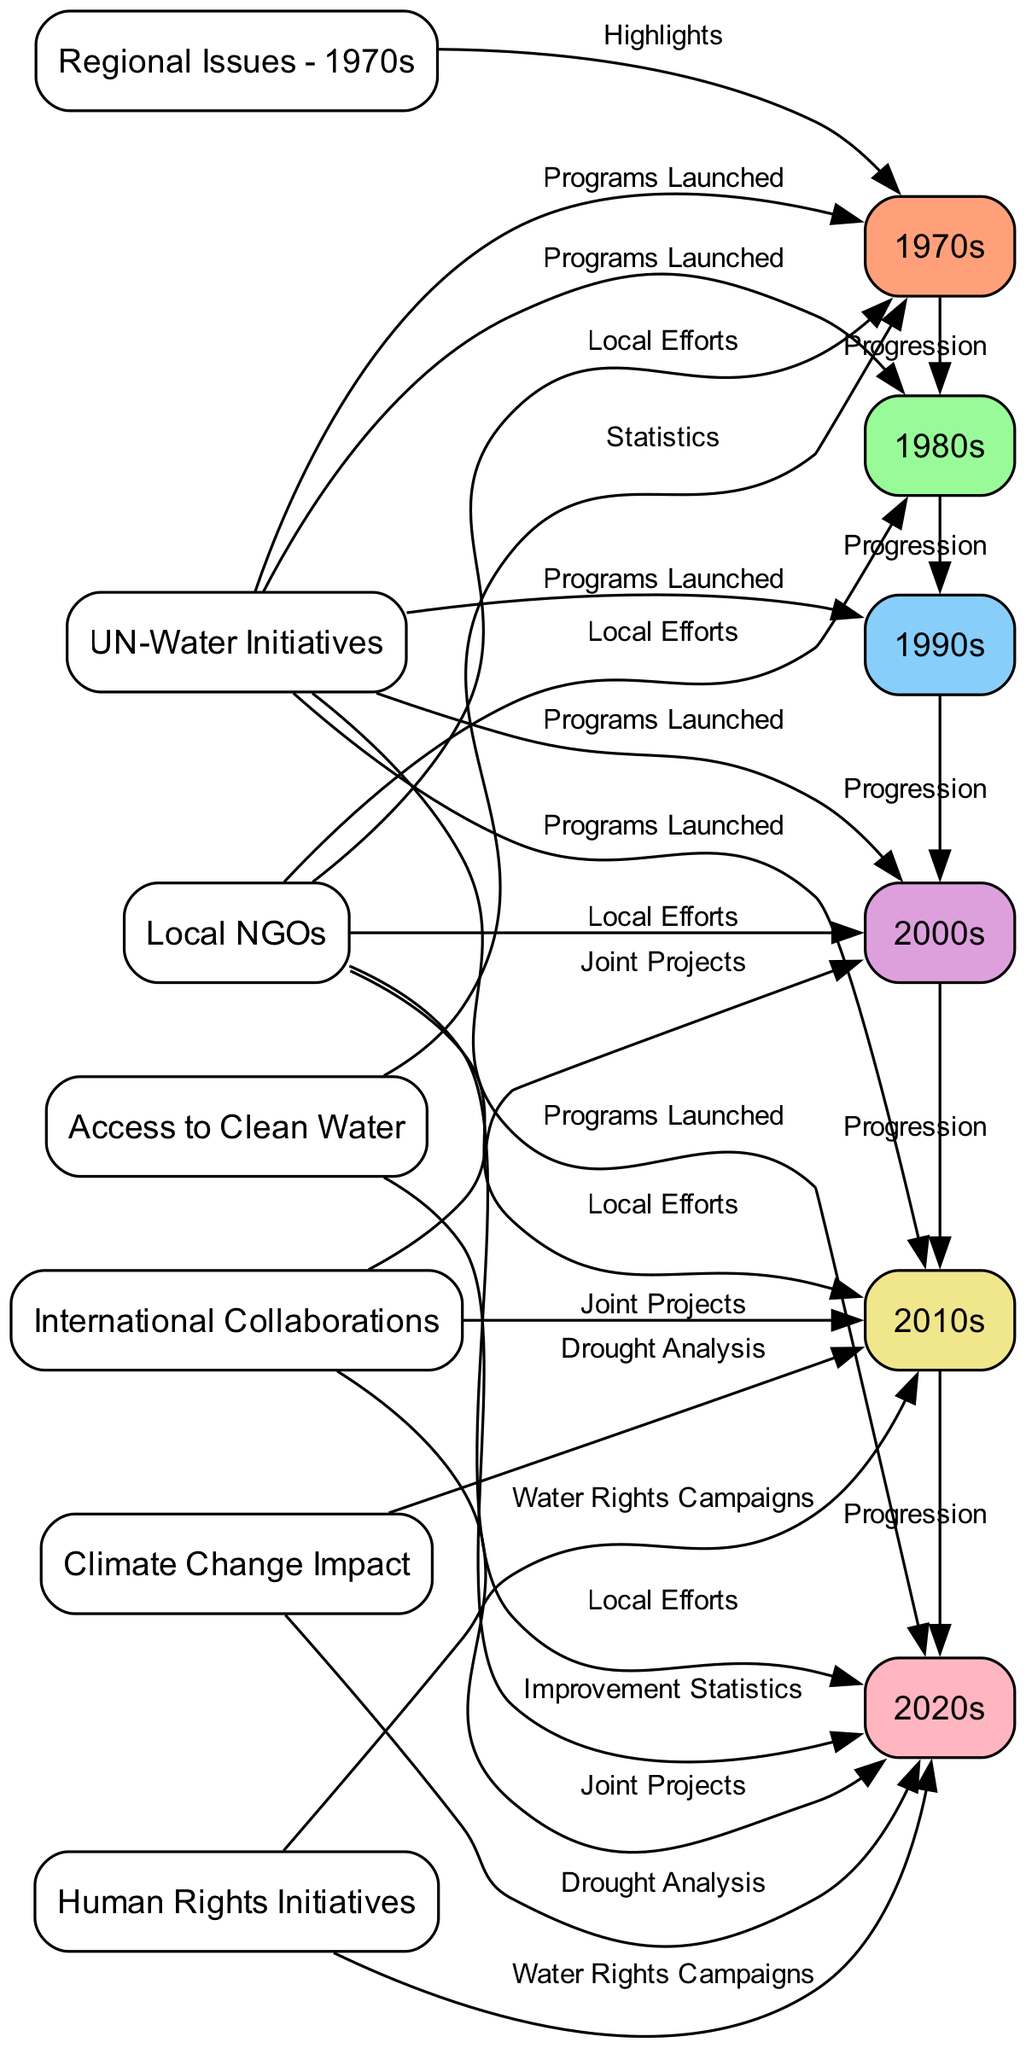What decade shows the first UN-Water initiatives? The diagram connects UN-Water initiatives to the 1970s directly, indicating that this is the first decade where these programs were launched.
Answer: 1970s How many decades are represented in the diagram? The nodes show six decades from the 1970s to the 2020s, which can be counted to determine the total number of decades represented.
Answer: 6 Which decade is linked to the highest number of local NGO efforts? By observing the edges from the local NGO node, it can be seen that efforts are noted in the 1970s, 1980s, 2000s, 2010s, and 2020s. Only the 1990s is missing, but there are edges to nearly all other decades, indicating they are all linked.
Answer: 5 In which decade do human rights initiatives specifically include water rights campaigns? The diagram indicates that human rights initiatives are specifically linked to the water rights campaigns in both the 2010s and 2020s.
Answer: 2010s, 2020s What impact does climate change have according to the diagram? The diagram shows the climate change impact linked to drought analysis in both the 2010s and 2020s, indicating that this is an ongoing concern.
Answer: Drought Analysis How is the progression between the decades represented in the diagram? The diagram shows a linear progression where each decade is connected by an edge labeled "Progression," indicating an evolution of water scarcity issues and responses across time.
Answer: Progression 